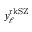<formula> <loc_0><loc_0><loc_500><loc_500>y _ { \ell } ^ { r k S Z }</formula> 